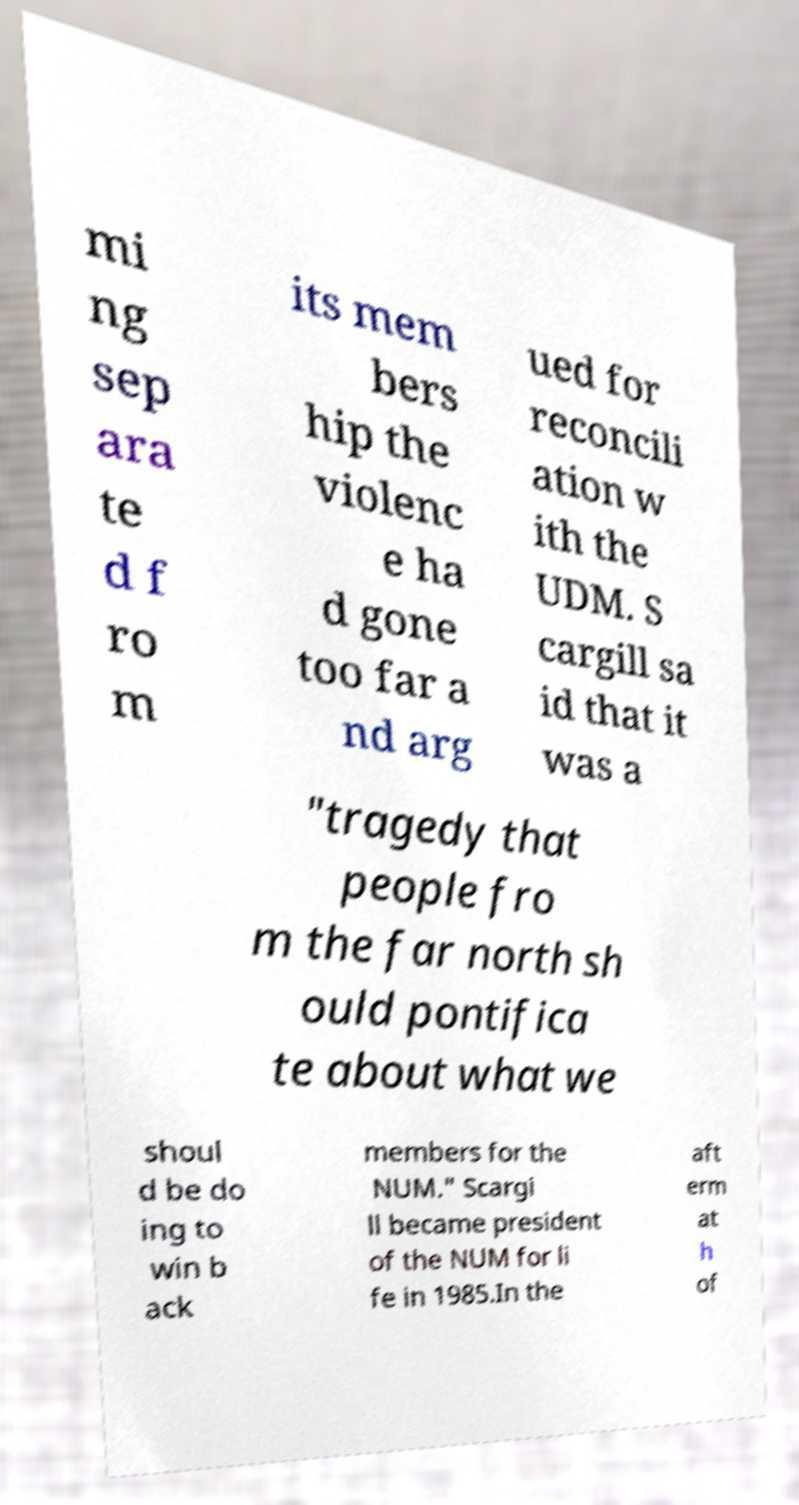There's text embedded in this image that I need extracted. Can you transcribe it verbatim? mi ng sep ara te d f ro m its mem bers hip the violenc e ha d gone too far a nd arg ued for reconcili ation w ith the UDM. S cargill sa id that it was a "tragedy that people fro m the far north sh ould pontifica te about what we shoul d be do ing to win b ack members for the NUM." Scargi ll became president of the NUM for li fe in 1985.In the aft erm at h of 